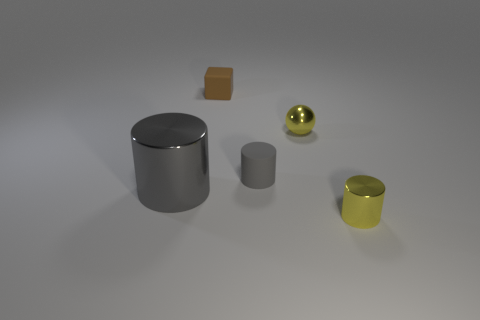Is the color of the big metallic object the same as the rubber cylinder?
Your answer should be compact. Yes. Is the color of the tiny metallic cylinder the same as the small metallic object that is behind the large thing?
Keep it short and to the point. Yes. What is the material of the thing that is the same color as the ball?
Offer a terse response. Metal. The big cylinder that is made of the same material as the tiny sphere is what color?
Offer a very short reply. Gray. There is a metal object to the left of the small yellow thing to the left of the small yellow metal object in front of the small ball; what size is it?
Provide a short and direct response. Large. Is the number of gray shiny things less than the number of gray things?
Your answer should be compact. Yes. There is a rubber thing that is the same shape as the gray metal thing; what is its color?
Give a very brief answer. Gray. Is there a tiny yellow thing on the right side of the yellow metallic thing on the left side of the tiny shiny object that is in front of the big gray metallic object?
Make the answer very short. Yes. Is the shape of the large thing the same as the brown rubber thing?
Provide a succinct answer. No. Is the number of matte cylinders left of the big object less than the number of cylinders?
Offer a terse response. Yes. 